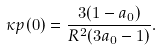<formula> <loc_0><loc_0><loc_500><loc_500>\kappa p ( 0 ) = \frac { 3 ( 1 - a _ { 0 } ) } { R ^ { 2 } ( 3 a _ { 0 } - 1 ) } .</formula> 